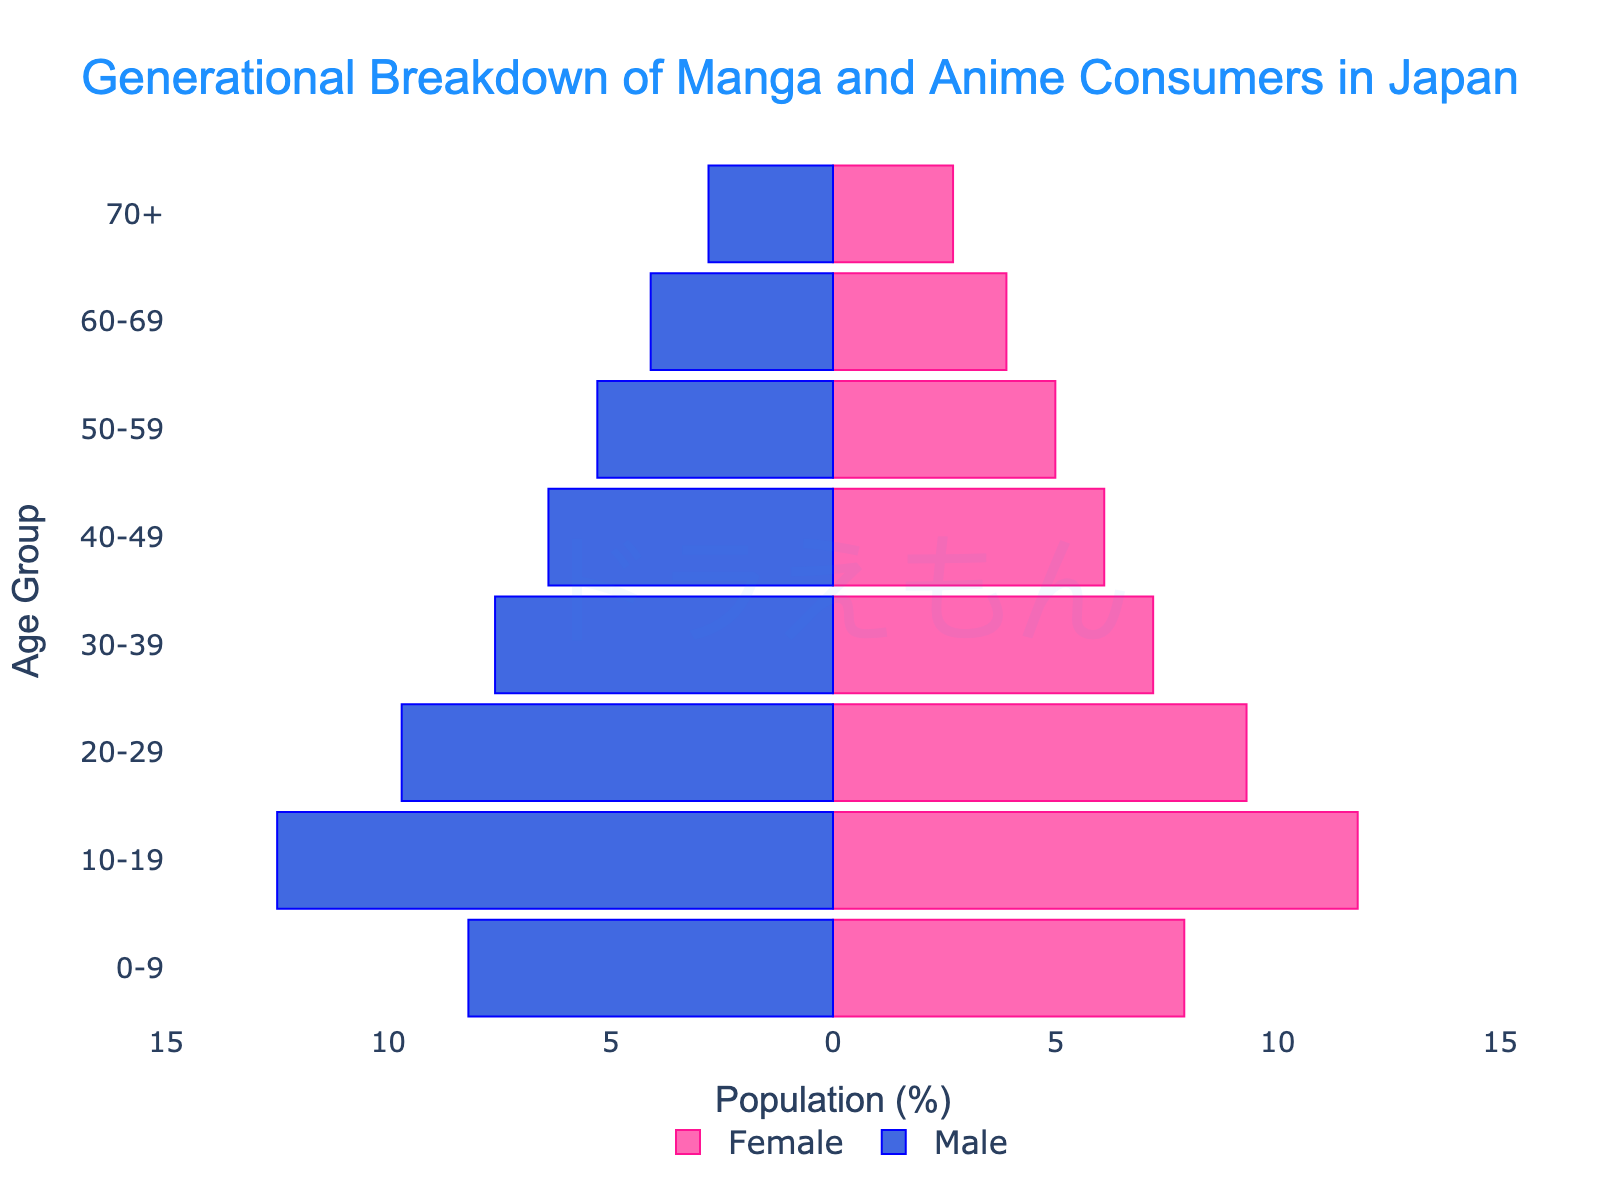What's the title of the figure? The title is located at the top of the figure and reads "Generational Breakdown of Manga and Anime Consumers in Japan."
Answer: Generational Breakdown of Manga and Anime Consumers in Japan What color represents the female population in the figure? The bars representing the female population are colored pink.
Answer: Pink What age group has the highest percentage of male consumers? The age group with the highest percentage of male consumers in the figure is displayed with the longest bar extending to the left. This group is 10-19.
Answer: 10-19 What's the difference in percentage between male and female consumers in the 10-19 age group? To find the difference, subtract the percentage of female consumers from male consumers in the 10-19 age group: 12.5 (male) - 11.8 (female) = 0.7.
Answer: 0.7 Which age group has the least percentage of manga and anime consumers overall? The age group with the shortest combined bars (both male and female) would have the least percentage of consumers. The 70+ age group has the smallest bars.
Answer: 70+ What's the total percentage of female consumers in the 30-39 and 40-49 age groups combined? Add the percentages of female consumers in the 30-39 and 40-49 age groups: 7.2 (30-39) + 6.1 (40-49) = 13.3.
Answer: 13.3 Which gender has a higher percentage of consumers in the 50-59 age group? Compare the length of the bars for male and female consumers in the 50-59 age group. The bar representing male consumers (5.3) is longer than the bar for female consumers (5.0).
Answer: Male What's the median age group for male consumers? The median age group is the one where the cumulative percentage from the smallest to the largest reaches the middle value. Look at the percentages until reaching the middle group. Middle groups for males are within the 20-29 age range.
Answer: 20-29 How can you tell that Doraemon's popularity is highlighted in the figure? Doraemon's name appears as a watermark text "ドラえもん" in the background center of the figure with translucent coloring, indicating it is meant to highlight Doraemon's popularity.
Answer: Doraemon watermark 